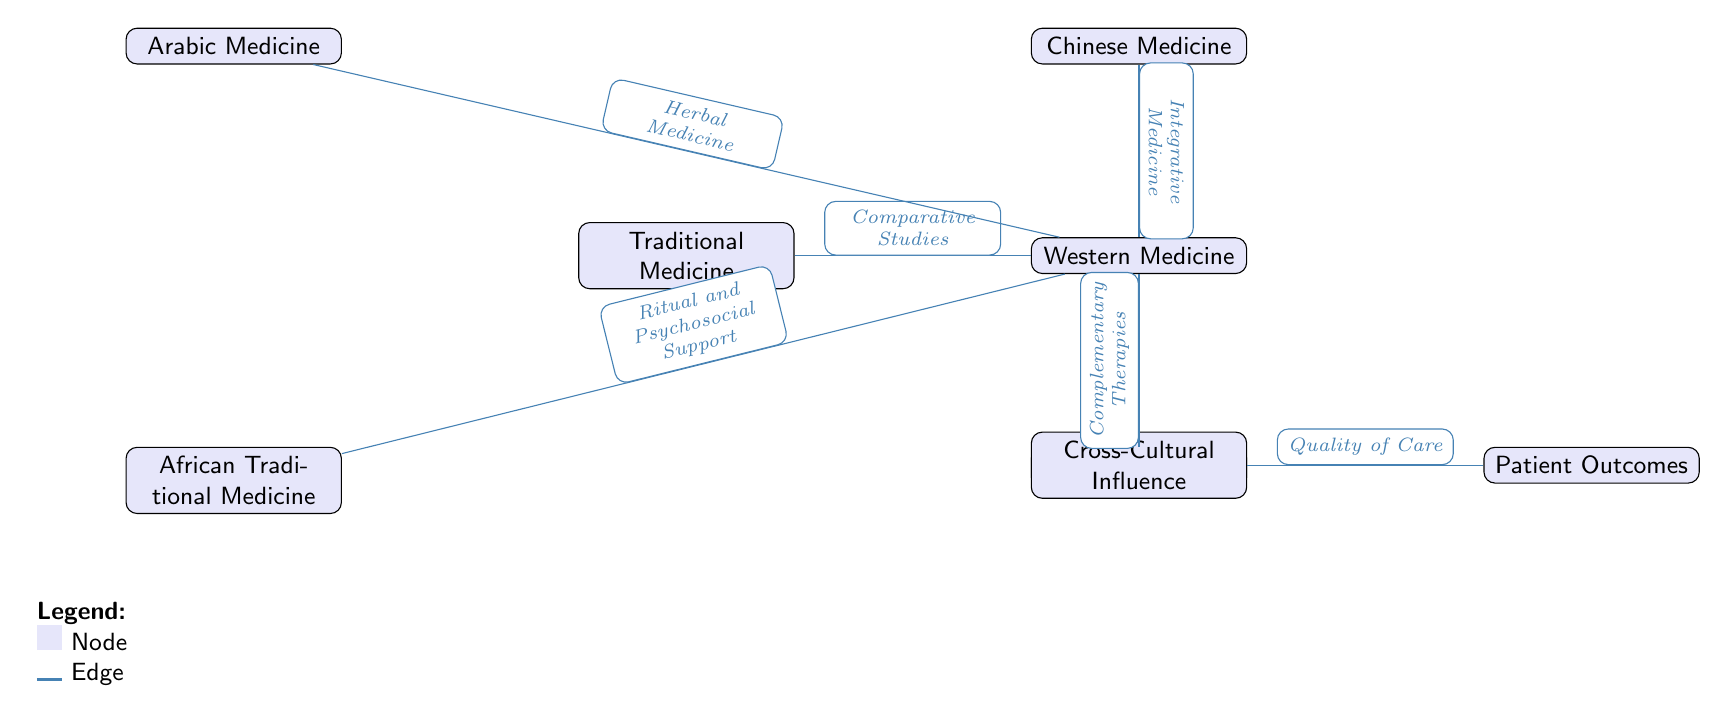What are the six types of medical practices depicted in the diagram? The diagram lists six types of medical practices in nodes: Traditional Medicine, Western Medicine, Chinese Medicine, Ayurveda, Arabic Medicine, and African Traditional Medicine.
Answer: Traditional Medicine, Western Medicine, Chinese Medicine, Ayurveda, Arabic Medicine, African Traditional Medicine Which type of medical practice is connected to patient outcomes? The edge labeled "Quality of Care" connects the "Cross-Cultural Influence" node to the "Patient Outcomes" node.
Answer: Cross-Cultural Influence How many edges are shown in the diagram? The diagram has five edges connecting various medical practices to Western Medicine, and one edge connecting Cross-Cultural Influence to Patient Outcomes, totaling six edges.
Answer: 6 What type of support does African Traditional Medicine provide according to the diagram? The edge from African Traditional Medicine to Western Medicine is labeled "Ritual and Psychosocial Support."
Answer: Ritual and Psychosocial Support Which medical practice contributes to integrative medicine? The arrow labeled "Integrative Medicine" connects Chinese Medicine to Western Medicine, indicating that Chinese Medicine contributes to this practice.
Answer: Chinese Medicine What is the primary connection between Western Medicine and the other practices shown? The edges from each of the traditional medical practices (Traditional Medicine, Chinese Medicine, Ayurveda, Arabic Medicine, and African Traditional Medicine) to Western Medicine demonstrate a comparative or collaborative relationship.
Answer: Comparative Studies, Integrative Medicine, Complementary Therapies, Herbal Medicine, Ritual and Psychosocial Support 